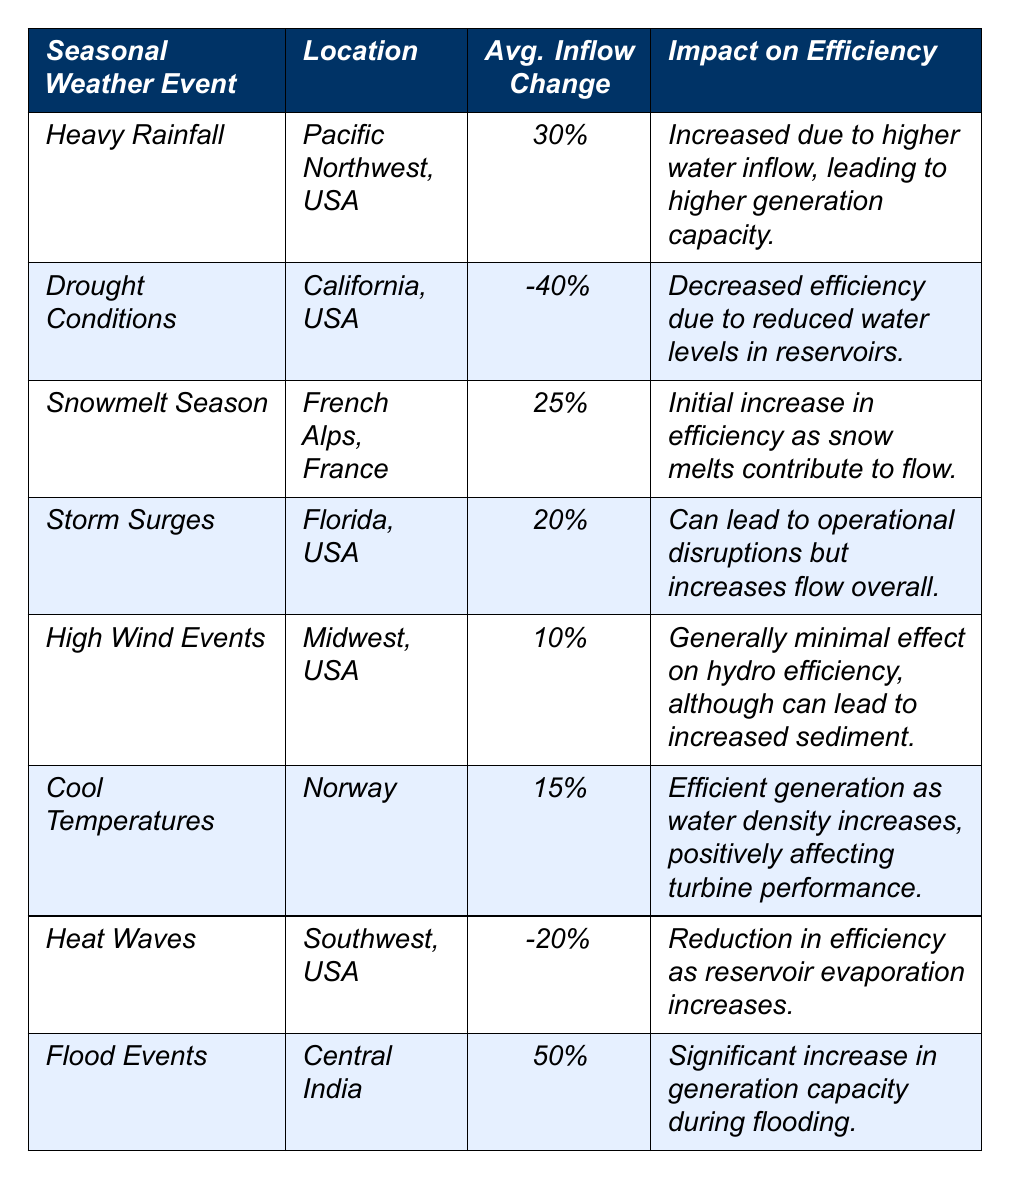What is the average inflow change percent for Heavy Rainfall? The table states that for Heavy Rainfall, the average inflow change percent is 30%.
Answer: 30% Which weather event is associated with the highest average inflow change percent? The event with the highest average inflow change percent is Flood Events, with an inflow change of 50%.
Answer: Flood Events Did High Wind Events have a positive impact on hydroelectric power efficiency? The information in the table indicates that High Wind Events generally have a minimal effect on hydro efficiency. Therefore, we assess this as a no.
Answer: No How much percent does the average inflow change decrease during Drought Conditions? The table shows that during Drought Conditions, the average inflow change percent is -40%.
Answer: -40% What is the average inflow change percent for Cool Temperatures and Heat Waves combined? For Cool Temperatures, the average inflow change percent is 15%, and for Heat Waves, it is -20%. The sum of these values is 15 + (-20) = -5. Since there are two events, the average is -5/2 = -2.5%.
Answer: -2.5% Which two events positively impact hydroelectric power generation efficiency? From the table, Heavy Rainfall and Flood Events both lead to increased generation capacity due to higher inflow.
Answer: Heavy Rainfall and Flood Events Do Storm Surges lead to an overall increase in flow? The table indicates that Storm Surges can lead to operational disruptions but overall increase flow. This indicates that the statement is true.
Answer: Yes Calculate the difference in average inflow change percent between Flood Events and Drought Conditions. Flood Events have an inflow change percent of 50%, while Drought Conditions have -40%. The difference is 50 - (-40) = 90%.
Answer: 90% 